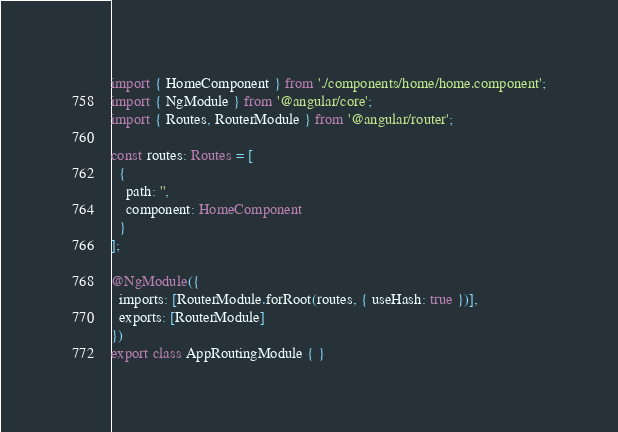<code> <loc_0><loc_0><loc_500><loc_500><_TypeScript_>import { HomeComponent } from './components/home/home.component';
import { NgModule } from '@angular/core';
import { Routes, RouterModule } from '@angular/router';

const routes: Routes = [
  {
    path: '',
    component: HomeComponent
  }
];

@NgModule({
  imports: [RouterModule.forRoot(routes, { useHash: true })],
  exports: [RouterModule]
})
export class AppRoutingModule { }
</code> 